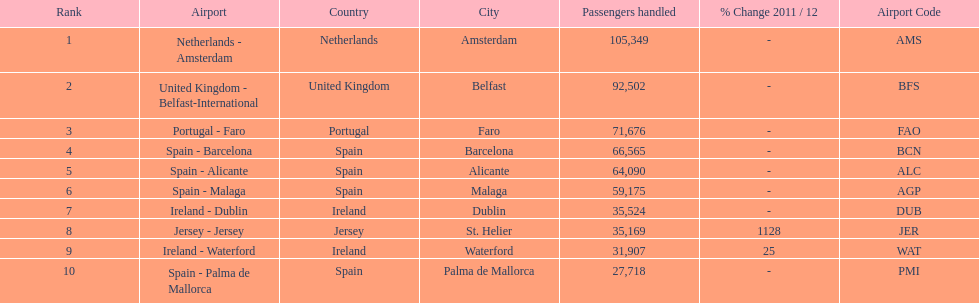Which airport has the least amount of passengers going through london southend airport? Spain - Palma de Mallorca. 